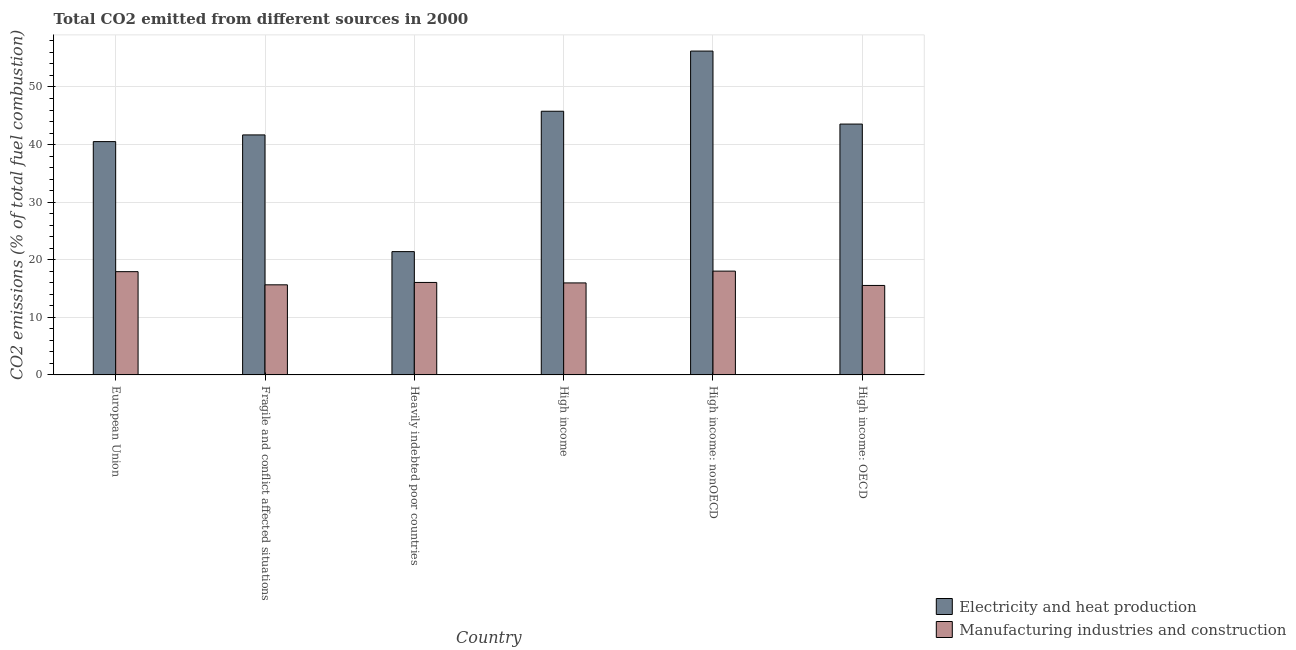Are the number of bars on each tick of the X-axis equal?
Your answer should be very brief. Yes. How many bars are there on the 4th tick from the left?
Your response must be concise. 2. What is the label of the 5th group of bars from the left?
Your answer should be very brief. High income: nonOECD. What is the co2 emissions due to manufacturing industries in European Union?
Keep it short and to the point. 17.93. Across all countries, what is the maximum co2 emissions due to manufacturing industries?
Your answer should be compact. 18.02. Across all countries, what is the minimum co2 emissions due to electricity and heat production?
Offer a terse response. 21.41. In which country was the co2 emissions due to electricity and heat production maximum?
Offer a very short reply. High income: nonOECD. In which country was the co2 emissions due to manufacturing industries minimum?
Offer a terse response. High income: OECD. What is the total co2 emissions due to electricity and heat production in the graph?
Your answer should be compact. 249.17. What is the difference between the co2 emissions due to electricity and heat production in European Union and that in High income: OECD?
Your answer should be compact. -3.04. What is the difference between the co2 emissions due to electricity and heat production in High income: OECD and the co2 emissions due to manufacturing industries in European Union?
Make the answer very short. 25.63. What is the average co2 emissions due to electricity and heat production per country?
Provide a succinct answer. 41.53. What is the difference between the co2 emissions due to electricity and heat production and co2 emissions due to manufacturing industries in High income: nonOECD?
Your answer should be very brief. 38.21. In how many countries, is the co2 emissions due to electricity and heat production greater than 24 %?
Ensure brevity in your answer.  5. What is the ratio of the co2 emissions due to electricity and heat production in Fragile and conflict affected situations to that in Heavily indebted poor countries?
Ensure brevity in your answer.  1.95. Is the co2 emissions due to electricity and heat production in Fragile and conflict affected situations less than that in Heavily indebted poor countries?
Provide a short and direct response. No. What is the difference between the highest and the second highest co2 emissions due to manufacturing industries?
Your answer should be very brief. 0.1. What is the difference between the highest and the lowest co2 emissions due to manufacturing industries?
Keep it short and to the point. 2.49. Is the sum of the co2 emissions due to manufacturing industries in High income: OECD and High income: nonOECD greater than the maximum co2 emissions due to electricity and heat production across all countries?
Ensure brevity in your answer.  No. What does the 2nd bar from the left in Heavily indebted poor countries represents?
Provide a short and direct response. Manufacturing industries and construction. What does the 1st bar from the right in High income: nonOECD represents?
Make the answer very short. Manufacturing industries and construction. Are all the bars in the graph horizontal?
Provide a succinct answer. No. How many countries are there in the graph?
Offer a very short reply. 6. Does the graph contain any zero values?
Provide a succinct answer. No. How are the legend labels stacked?
Your answer should be compact. Vertical. What is the title of the graph?
Ensure brevity in your answer.  Total CO2 emitted from different sources in 2000. What is the label or title of the Y-axis?
Provide a succinct answer. CO2 emissions (% of total fuel combustion). What is the CO2 emissions (% of total fuel combustion) in Electricity and heat production in European Union?
Your answer should be compact. 40.51. What is the CO2 emissions (% of total fuel combustion) of Manufacturing industries and construction in European Union?
Your answer should be compact. 17.93. What is the CO2 emissions (% of total fuel combustion) of Electricity and heat production in Fragile and conflict affected situations?
Offer a very short reply. 41.67. What is the CO2 emissions (% of total fuel combustion) of Manufacturing industries and construction in Fragile and conflict affected situations?
Make the answer very short. 15.64. What is the CO2 emissions (% of total fuel combustion) of Electricity and heat production in Heavily indebted poor countries?
Your answer should be very brief. 21.41. What is the CO2 emissions (% of total fuel combustion) of Manufacturing industries and construction in Heavily indebted poor countries?
Ensure brevity in your answer.  16.06. What is the CO2 emissions (% of total fuel combustion) in Electricity and heat production in High income?
Offer a very short reply. 45.79. What is the CO2 emissions (% of total fuel combustion) in Manufacturing industries and construction in High income?
Provide a short and direct response. 15.97. What is the CO2 emissions (% of total fuel combustion) in Electricity and heat production in High income: nonOECD?
Offer a terse response. 56.23. What is the CO2 emissions (% of total fuel combustion) in Manufacturing industries and construction in High income: nonOECD?
Your answer should be very brief. 18.02. What is the CO2 emissions (% of total fuel combustion) of Electricity and heat production in High income: OECD?
Keep it short and to the point. 43.56. What is the CO2 emissions (% of total fuel combustion) of Manufacturing industries and construction in High income: OECD?
Your response must be concise. 15.54. Across all countries, what is the maximum CO2 emissions (% of total fuel combustion) of Electricity and heat production?
Ensure brevity in your answer.  56.23. Across all countries, what is the maximum CO2 emissions (% of total fuel combustion) of Manufacturing industries and construction?
Your answer should be very brief. 18.02. Across all countries, what is the minimum CO2 emissions (% of total fuel combustion) of Electricity and heat production?
Give a very brief answer. 21.41. Across all countries, what is the minimum CO2 emissions (% of total fuel combustion) of Manufacturing industries and construction?
Offer a terse response. 15.54. What is the total CO2 emissions (% of total fuel combustion) in Electricity and heat production in the graph?
Provide a succinct answer. 249.17. What is the total CO2 emissions (% of total fuel combustion) of Manufacturing industries and construction in the graph?
Offer a very short reply. 99.16. What is the difference between the CO2 emissions (% of total fuel combustion) of Electricity and heat production in European Union and that in Fragile and conflict affected situations?
Give a very brief answer. -1.16. What is the difference between the CO2 emissions (% of total fuel combustion) of Manufacturing industries and construction in European Union and that in Fragile and conflict affected situations?
Ensure brevity in your answer.  2.29. What is the difference between the CO2 emissions (% of total fuel combustion) of Electricity and heat production in European Union and that in Heavily indebted poor countries?
Provide a short and direct response. 19.1. What is the difference between the CO2 emissions (% of total fuel combustion) in Manufacturing industries and construction in European Union and that in Heavily indebted poor countries?
Your answer should be very brief. 1.87. What is the difference between the CO2 emissions (% of total fuel combustion) of Electricity and heat production in European Union and that in High income?
Keep it short and to the point. -5.27. What is the difference between the CO2 emissions (% of total fuel combustion) of Manufacturing industries and construction in European Union and that in High income?
Make the answer very short. 1.95. What is the difference between the CO2 emissions (% of total fuel combustion) of Electricity and heat production in European Union and that in High income: nonOECD?
Your answer should be compact. -15.72. What is the difference between the CO2 emissions (% of total fuel combustion) in Manufacturing industries and construction in European Union and that in High income: nonOECD?
Offer a terse response. -0.1. What is the difference between the CO2 emissions (% of total fuel combustion) in Electricity and heat production in European Union and that in High income: OECD?
Offer a very short reply. -3.04. What is the difference between the CO2 emissions (% of total fuel combustion) of Manufacturing industries and construction in European Union and that in High income: OECD?
Ensure brevity in your answer.  2.39. What is the difference between the CO2 emissions (% of total fuel combustion) of Electricity and heat production in Fragile and conflict affected situations and that in Heavily indebted poor countries?
Provide a short and direct response. 20.27. What is the difference between the CO2 emissions (% of total fuel combustion) in Manufacturing industries and construction in Fragile and conflict affected situations and that in Heavily indebted poor countries?
Provide a succinct answer. -0.41. What is the difference between the CO2 emissions (% of total fuel combustion) of Electricity and heat production in Fragile and conflict affected situations and that in High income?
Provide a short and direct response. -4.11. What is the difference between the CO2 emissions (% of total fuel combustion) of Manufacturing industries and construction in Fragile and conflict affected situations and that in High income?
Give a very brief answer. -0.33. What is the difference between the CO2 emissions (% of total fuel combustion) of Electricity and heat production in Fragile and conflict affected situations and that in High income: nonOECD?
Your response must be concise. -14.56. What is the difference between the CO2 emissions (% of total fuel combustion) of Manufacturing industries and construction in Fragile and conflict affected situations and that in High income: nonOECD?
Make the answer very short. -2.38. What is the difference between the CO2 emissions (% of total fuel combustion) in Electricity and heat production in Fragile and conflict affected situations and that in High income: OECD?
Make the answer very short. -1.88. What is the difference between the CO2 emissions (% of total fuel combustion) of Manufacturing industries and construction in Fragile and conflict affected situations and that in High income: OECD?
Your response must be concise. 0.11. What is the difference between the CO2 emissions (% of total fuel combustion) of Electricity and heat production in Heavily indebted poor countries and that in High income?
Keep it short and to the point. -24.38. What is the difference between the CO2 emissions (% of total fuel combustion) of Manufacturing industries and construction in Heavily indebted poor countries and that in High income?
Offer a very short reply. 0.08. What is the difference between the CO2 emissions (% of total fuel combustion) in Electricity and heat production in Heavily indebted poor countries and that in High income: nonOECD?
Your answer should be very brief. -34.83. What is the difference between the CO2 emissions (% of total fuel combustion) in Manufacturing industries and construction in Heavily indebted poor countries and that in High income: nonOECD?
Your answer should be very brief. -1.97. What is the difference between the CO2 emissions (% of total fuel combustion) in Electricity and heat production in Heavily indebted poor countries and that in High income: OECD?
Keep it short and to the point. -22.15. What is the difference between the CO2 emissions (% of total fuel combustion) of Manufacturing industries and construction in Heavily indebted poor countries and that in High income: OECD?
Offer a very short reply. 0.52. What is the difference between the CO2 emissions (% of total fuel combustion) of Electricity and heat production in High income and that in High income: nonOECD?
Make the answer very short. -10.45. What is the difference between the CO2 emissions (% of total fuel combustion) in Manufacturing industries and construction in High income and that in High income: nonOECD?
Offer a very short reply. -2.05. What is the difference between the CO2 emissions (% of total fuel combustion) in Electricity and heat production in High income and that in High income: OECD?
Your answer should be very brief. 2.23. What is the difference between the CO2 emissions (% of total fuel combustion) of Manufacturing industries and construction in High income and that in High income: OECD?
Your response must be concise. 0.44. What is the difference between the CO2 emissions (% of total fuel combustion) of Electricity and heat production in High income: nonOECD and that in High income: OECD?
Provide a short and direct response. 12.68. What is the difference between the CO2 emissions (% of total fuel combustion) of Manufacturing industries and construction in High income: nonOECD and that in High income: OECD?
Offer a terse response. 2.49. What is the difference between the CO2 emissions (% of total fuel combustion) in Electricity and heat production in European Union and the CO2 emissions (% of total fuel combustion) in Manufacturing industries and construction in Fragile and conflict affected situations?
Offer a terse response. 24.87. What is the difference between the CO2 emissions (% of total fuel combustion) in Electricity and heat production in European Union and the CO2 emissions (% of total fuel combustion) in Manufacturing industries and construction in Heavily indebted poor countries?
Your response must be concise. 24.46. What is the difference between the CO2 emissions (% of total fuel combustion) of Electricity and heat production in European Union and the CO2 emissions (% of total fuel combustion) of Manufacturing industries and construction in High income?
Provide a short and direct response. 24.54. What is the difference between the CO2 emissions (% of total fuel combustion) in Electricity and heat production in European Union and the CO2 emissions (% of total fuel combustion) in Manufacturing industries and construction in High income: nonOECD?
Provide a short and direct response. 22.49. What is the difference between the CO2 emissions (% of total fuel combustion) of Electricity and heat production in European Union and the CO2 emissions (% of total fuel combustion) of Manufacturing industries and construction in High income: OECD?
Keep it short and to the point. 24.98. What is the difference between the CO2 emissions (% of total fuel combustion) in Electricity and heat production in Fragile and conflict affected situations and the CO2 emissions (% of total fuel combustion) in Manufacturing industries and construction in Heavily indebted poor countries?
Your answer should be very brief. 25.62. What is the difference between the CO2 emissions (% of total fuel combustion) in Electricity and heat production in Fragile and conflict affected situations and the CO2 emissions (% of total fuel combustion) in Manufacturing industries and construction in High income?
Provide a short and direct response. 25.7. What is the difference between the CO2 emissions (% of total fuel combustion) of Electricity and heat production in Fragile and conflict affected situations and the CO2 emissions (% of total fuel combustion) of Manufacturing industries and construction in High income: nonOECD?
Your answer should be compact. 23.65. What is the difference between the CO2 emissions (% of total fuel combustion) in Electricity and heat production in Fragile and conflict affected situations and the CO2 emissions (% of total fuel combustion) in Manufacturing industries and construction in High income: OECD?
Give a very brief answer. 26.14. What is the difference between the CO2 emissions (% of total fuel combustion) in Electricity and heat production in Heavily indebted poor countries and the CO2 emissions (% of total fuel combustion) in Manufacturing industries and construction in High income?
Make the answer very short. 5.43. What is the difference between the CO2 emissions (% of total fuel combustion) in Electricity and heat production in Heavily indebted poor countries and the CO2 emissions (% of total fuel combustion) in Manufacturing industries and construction in High income: nonOECD?
Make the answer very short. 3.38. What is the difference between the CO2 emissions (% of total fuel combustion) in Electricity and heat production in Heavily indebted poor countries and the CO2 emissions (% of total fuel combustion) in Manufacturing industries and construction in High income: OECD?
Your answer should be compact. 5.87. What is the difference between the CO2 emissions (% of total fuel combustion) of Electricity and heat production in High income and the CO2 emissions (% of total fuel combustion) of Manufacturing industries and construction in High income: nonOECD?
Offer a terse response. 27.76. What is the difference between the CO2 emissions (% of total fuel combustion) in Electricity and heat production in High income and the CO2 emissions (% of total fuel combustion) in Manufacturing industries and construction in High income: OECD?
Keep it short and to the point. 30.25. What is the difference between the CO2 emissions (% of total fuel combustion) in Electricity and heat production in High income: nonOECD and the CO2 emissions (% of total fuel combustion) in Manufacturing industries and construction in High income: OECD?
Your answer should be very brief. 40.7. What is the average CO2 emissions (% of total fuel combustion) in Electricity and heat production per country?
Keep it short and to the point. 41.53. What is the average CO2 emissions (% of total fuel combustion) of Manufacturing industries and construction per country?
Give a very brief answer. 16.53. What is the difference between the CO2 emissions (% of total fuel combustion) of Electricity and heat production and CO2 emissions (% of total fuel combustion) of Manufacturing industries and construction in European Union?
Keep it short and to the point. 22.58. What is the difference between the CO2 emissions (% of total fuel combustion) of Electricity and heat production and CO2 emissions (% of total fuel combustion) of Manufacturing industries and construction in Fragile and conflict affected situations?
Your response must be concise. 26.03. What is the difference between the CO2 emissions (% of total fuel combustion) in Electricity and heat production and CO2 emissions (% of total fuel combustion) in Manufacturing industries and construction in Heavily indebted poor countries?
Your answer should be very brief. 5.35. What is the difference between the CO2 emissions (% of total fuel combustion) in Electricity and heat production and CO2 emissions (% of total fuel combustion) in Manufacturing industries and construction in High income?
Ensure brevity in your answer.  29.81. What is the difference between the CO2 emissions (% of total fuel combustion) of Electricity and heat production and CO2 emissions (% of total fuel combustion) of Manufacturing industries and construction in High income: nonOECD?
Provide a succinct answer. 38.21. What is the difference between the CO2 emissions (% of total fuel combustion) of Electricity and heat production and CO2 emissions (% of total fuel combustion) of Manufacturing industries and construction in High income: OECD?
Your answer should be very brief. 28.02. What is the ratio of the CO2 emissions (% of total fuel combustion) of Electricity and heat production in European Union to that in Fragile and conflict affected situations?
Ensure brevity in your answer.  0.97. What is the ratio of the CO2 emissions (% of total fuel combustion) in Manufacturing industries and construction in European Union to that in Fragile and conflict affected situations?
Your answer should be compact. 1.15. What is the ratio of the CO2 emissions (% of total fuel combustion) in Electricity and heat production in European Union to that in Heavily indebted poor countries?
Your answer should be compact. 1.89. What is the ratio of the CO2 emissions (% of total fuel combustion) of Manufacturing industries and construction in European Union to that in Heavily indebted poor countries?
Your answer should be compact. 1.12. What is the ratio of the CO2 emissions (% of total fuel combustion) in Electricity and heat production in European Union to that in High income?
Your response must be concise. 0.88. What is the ratio of the CO2 emissions (% of total fuel combustion) of Manufacturing industries and construction in European Union to that in High income?
Your response must be concise. 1.12. What is the ratio of the CO2 emissions (% of total fuel combustion) of Electricity and heat production in European Union to that in High income: nonOECD?
Offer a very short reply. 0.72. What is the ratio of the CO2 emissions (% of total fuel combustion) of Electricity and heat production in European Union to that in High income: OECD?
Give a very brief answer. 0.93. What is the ratio of the CO2 emissions (% of total fuel combustion) in Manufacturing industries and construction in European Union to that in High income: OECD?
Give a very brief answer. 1.15. What is the ratio of the CO2 emissions (% of total fuel combustion) of Electricity and heat production in Fragile and conflict affected situations to that in Heavily indebted poor countries?
Offer a very short reply. 1.95. What is the ratio of the CO2 emissions (% of total fuel combustion) in Manufacturing industries and construction in Fragile and conflict affected situations to that in Heavily indebted poor countries?
Your answer should be very brief. 0.97. What is the ratio of the CO2 emissions (% of total fuel combustion) in Electricity and heat production in Fragile and conflict affected situations to that in High income?
Keep it short and to the point. 0.91. What is the ratio of the CO2 emissions (% of total fuel combustion) in Manufacturing industries and construction in Fragile and conflict affected situations to that in High income?
Keep it short and to the point. 0.98. What is the ratio of the CO2 emissions (% of total fuel combustion) of Electricity and heat production in Fragile and conflict affected situations to that in High income: nonOECD?
Your response must be concise. 0.74. What is the ratio of the CO2 emissions (% of total fuel combustion) of Manufacturing industries and construction in Fragile and conflict affected situations to that in High income: nonOECD?
Offer a very short reply. 0.87. What is the ratio of the CO2 emissions (% of total fuel combustion) of Electricity and heat production in Fragile and conflict affected situations to that in High income: OECD?
Offer a very short reply. 0.96. What is the ratio of the CO2 emissions (% of total fuel combustion) in Manufacturing industries and construction in Fragile and conflict affected situations to that in High income: OECD?
Your answer should be compact. 1.01. What is the ratio of the CO2 emissions (% of total fuel combustion) in Electricity and heat production in Heavily indebted poor countries to that in High income?
Provide a short and direct response. 0.47. What is the ratio of the CO2 emissions (% of total fuel combustion) of Electricity and heat production in Heavily indebted poor countries to that in High income: nonOECD?
Your response must be concise. 0.38. What is the ratio of the CO2 emissions (% of total fuel combustion) of Manufacturing industries and construction in Heavily indebted poor countries to that in High income: nonOECD?
Make the answer very short. 0.89. What is the ratio of the CO2 emissions (% of total fuel combustion) in Electricity and heat production in Heavily indebted poor countries to that in High income: OECD?
Offer a very short reply. 0.49. What is the ratio of the CO2 emissions (% of total fuel combustion) in Manufacturing industries and construction in Heavily indebted poor countries to that in High income: OECD?
Offer a very short reply. 1.03. What is the ratio of the CO2 emissions (% of total fuel combustion) in Electricity and heat production in High income to that in High income: nonOECD?
Your answer should be very brief. 0.81. What is the ratio of the CO2 emissions (% of total fuel combustion) in Manufacturing industries and construction in High income to that in High income: nonOECD?
Provide a short and direct response. 0.89. What is the ratio of the CO2 emissions (% of total fuel combustion) of Electricity and heat production in High income to that in High income: OECD?
Provide a succinct answer. 1.05. What is the ratio of the CO2 emissions (% of total fuel combustion) of Manufacturing industries and construction in High income to that in High income: OECD?
Your answer should be very brief. 1.03. What is the ratio of the CO2 emissions (% of total fuel combustion) in Electricity and heat production in High income: nonOECD to that in High income: OECD?
Your answer should be very brief. 1.29. What is the ratio of the CO2 emissions (% of total fuel combustion) in Manufacturing industries and construction in High income: nonOECD to that in High income: OECD?
Give a very brief answer. 1.16. What is the difference between the highest and the second highest CO2 emissions (% of total fuel combustion) in Electricity and heat production?
Ensure brevity in your answer.  10.45. What is the difference between the highest and the second highest CO2 emissions (% of total fuel combustion) in Manufacturing industries and construction?
Your answer should be compact. 0.1. What is the difference between the highest and the lowest CO2 emissions (% of total fuel combustion) of Electricity and heat production?
Keep it short and to the point. 34.83. What is the difference between the highest and the lowest CO2 emissions (% of total fuel combustion) of Manufacturing industries and construction?
Your response must be concise. 2.49. 